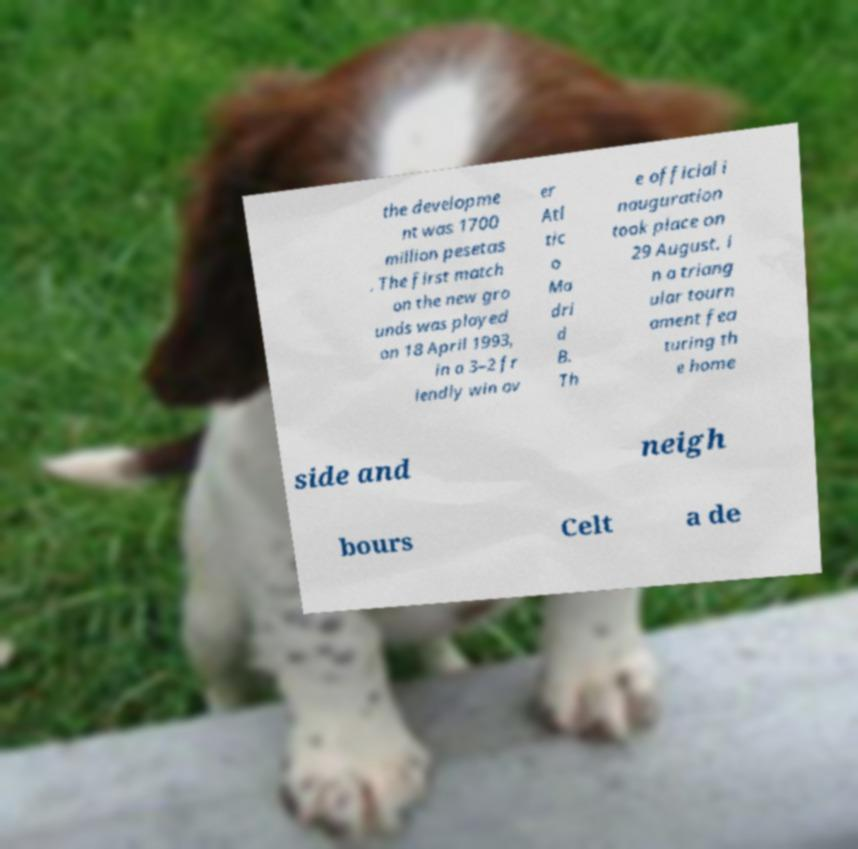There's text embedded in this image that I need extracted. Can you transcribe it verbatim? the developme nt was 1700 million pesetas . The first match on the new gro unds was played on 18 April 1993, in a 3–2 fr iendly win ov er Atl tic o Ma dri d B. Th e official i nauguration took place on 29 August, i n a triang ular tourn ament fea turing th e home side and neigh bours Celt a de 